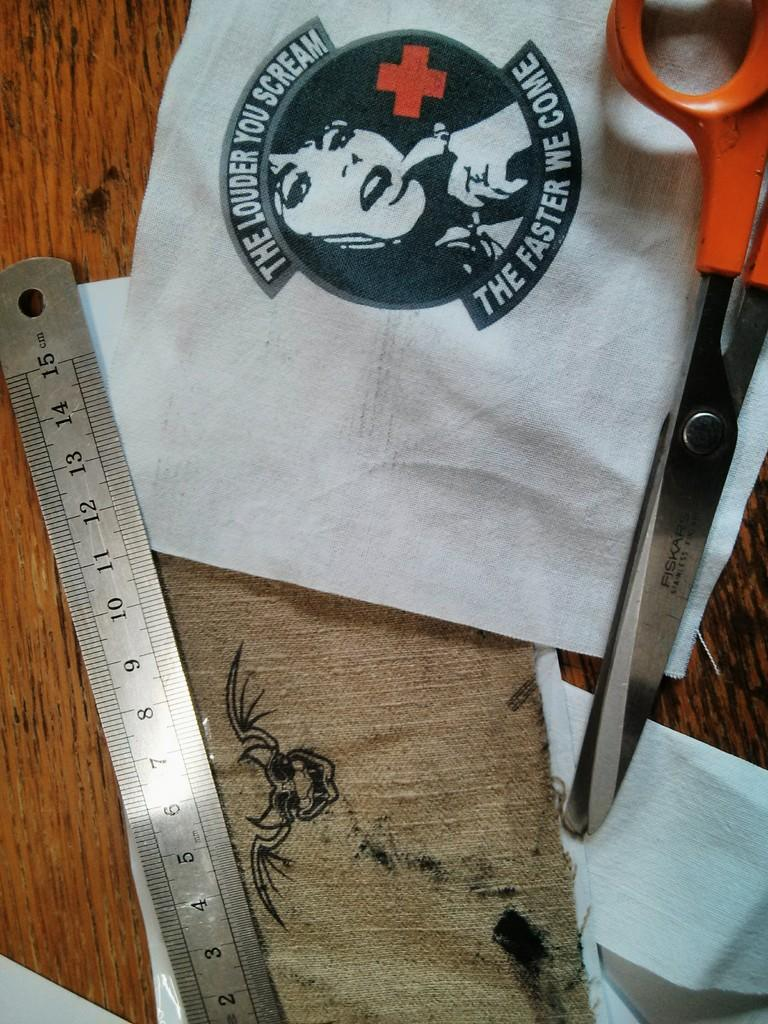<image>
Provide a brief description of the given image. White piece of napkin that says The Louder Your Scream on top. 